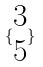<formula> <loc_0><loc_0><loc_500><loc_500>\{ \begin{matrix} 3 \\ 5 \end{matrix} \}</formula> 